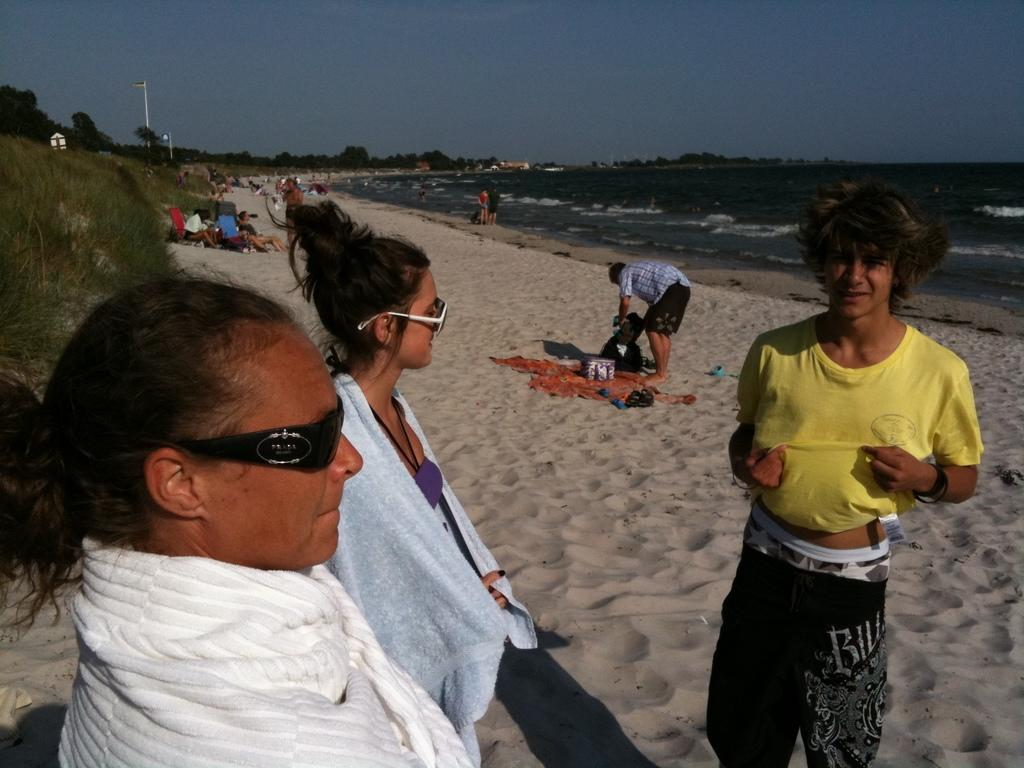How many people are in the image? There are people in the image, but the exact number is not specified. What are the people doing in the image? Some people are sitting on the ground, and some are standing on the ground. What can be seen in the background of the image? There is sky, water, trees, poles, and other unspecified objects visible in the background of the image. What type of pest can be seen crawling on the people's noses in the image? There is no pest visible on the people's noses in the image. What type of root is growing out of the ground near the people in the image? There is no root visible near the people in the image. 